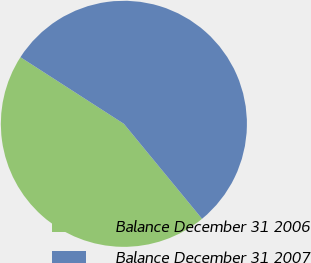Convert chart. <chart><loc_0><loc_0><loc_500><loc_500><pie_chart><fcel>Balance December 31 2006<fcel>Balance December 31 2007<nl><fcel>45.07%<fcel>54.93%<nl></chart> 